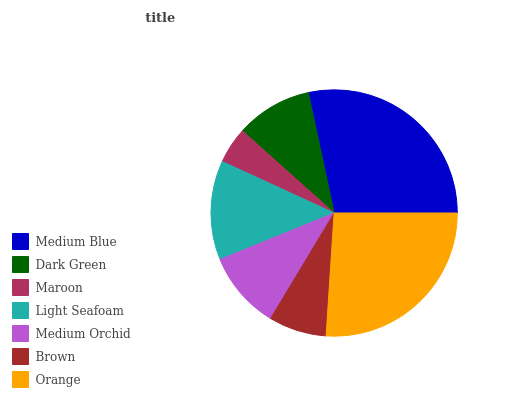Is Maroon the minimum?
Answer yes or no. Yes. Is Medium Blue the maximum?
Answer yes or no. Yes. Is Dark Green the minimum?
Answer yes or no. No. Is Dark Green the maximum?
Answer yes or no. No. Is Medium Blue greater than Dark Green?
Answer yes or no. Yes. Is Dark Green less than Medium Blue?
Answer yes or no. Yes. Is Dark Green greater than Medium Blue?
Answer yes or no. No. Is Medium Blue less than Dark Green?
Answer yes or no. No. Is Medium Orchid the high median?
Answer yes or no. Yes. Is Medium Orchid the low median?
Answer yes or no. Yes. Is Medium Blue the high median?
Answer yes or no. No. Is Light Seafoam the low median?
Answer yes or no. No. 